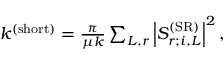Convert formula to latex. <formula><loc_0><loc_0><loc_500><loc_500>\begin{array} { r } { k ^ { ( s h o r t ) } = \frac { \pi } { \mu k } \sum _ { L , r } \left | S _ { r ; i , L } ^ { ( S R ) } \right | ^ { 2 } , } \end{array}</formula> 